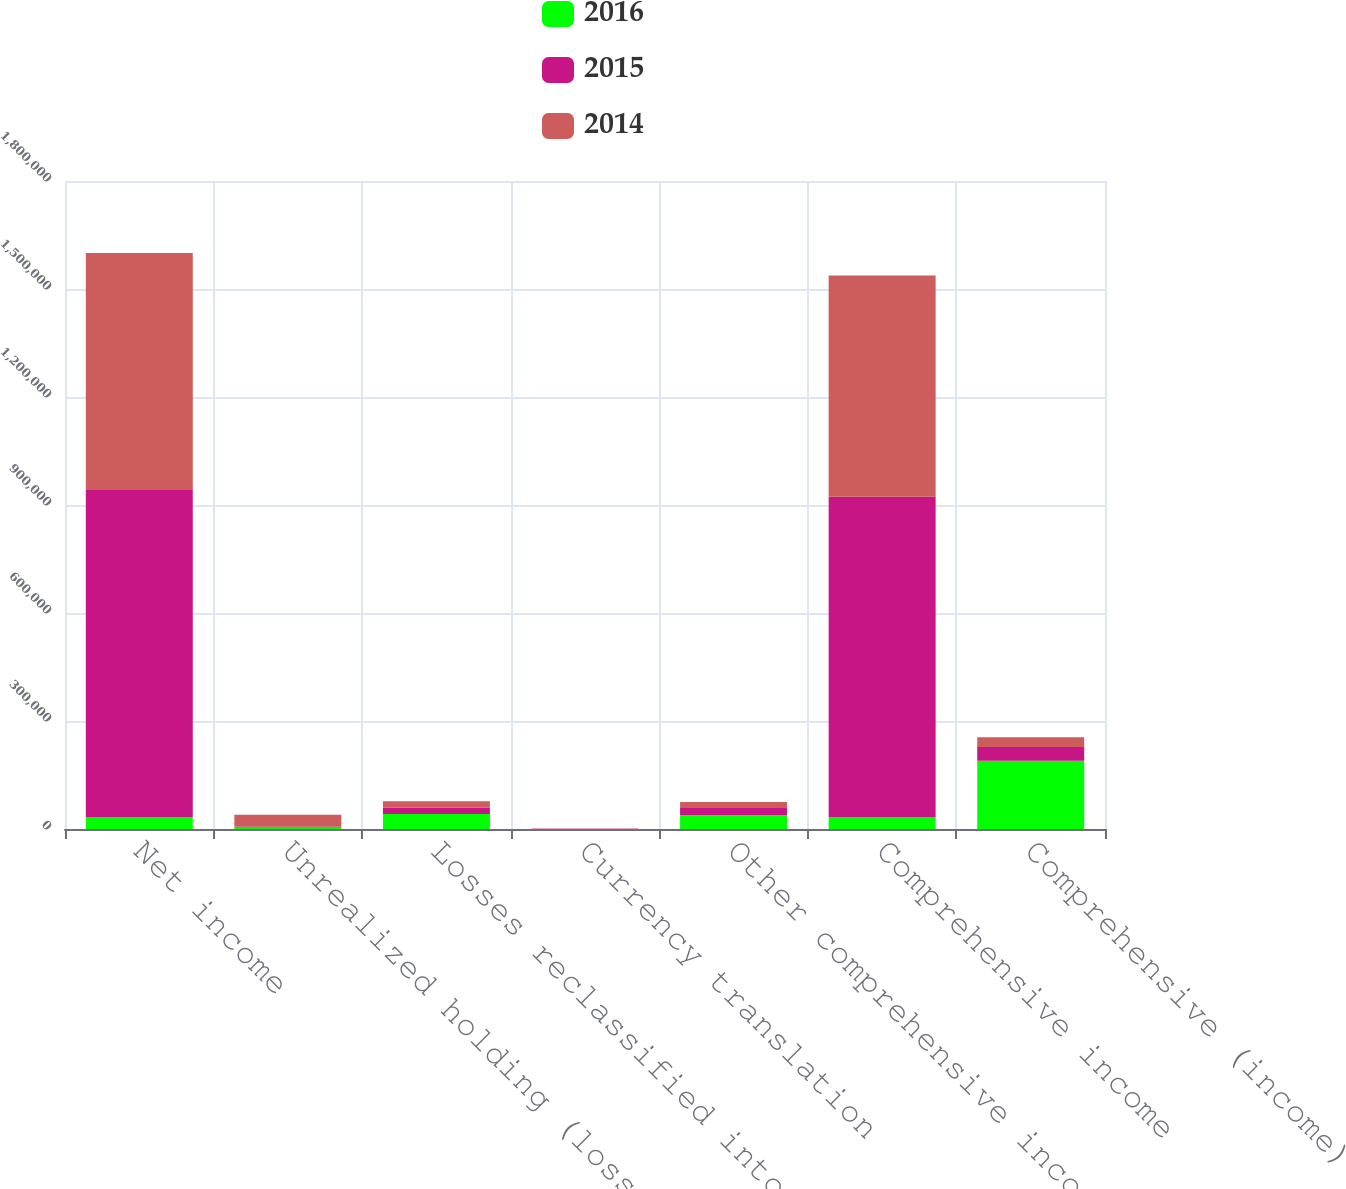Convert chart to OTSL. <chart><loc_0><loc_0><loc_500><loc_500><stacked_bar_chart><ecel><fcel>Net income<fcel>Unrealized holding (losses)<fcel>Losses reclassified into<fcel>Currency translation<fcel>Other comprehensive income<fcel>Comprehensive income<fcel>Comprehensive (income)<nl><fcel>2016<fcel>33306<fcel>3915<fcel>41758<fcel>264<fcel>38107<fcel>33306<fcel>189411<nl><fcel>2015<fcel>908018<fcel>2219<fcel>18244<fcel>327<fcel>20136<fcel>889486<fcel>38668<nl><fcel>2014<fcel>658683<fcel>33306<fcel>16868<fcel>552<fcel>16990<fcel>614965<fcel>26728<nl></chart> 